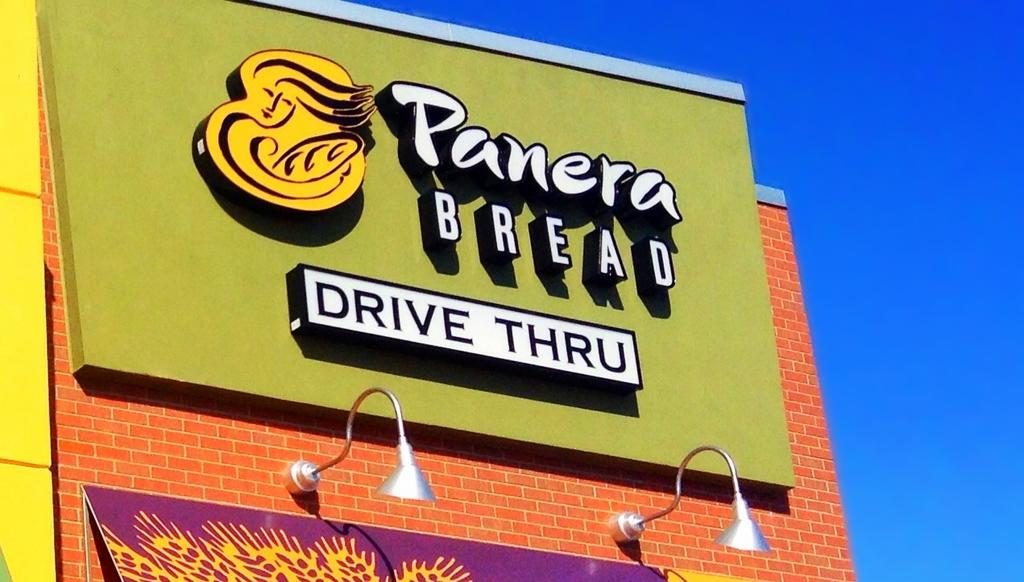<image>
Write a terse but informative summary of the picture. A Panera Bread sign says Drive Thru on a brick building. 